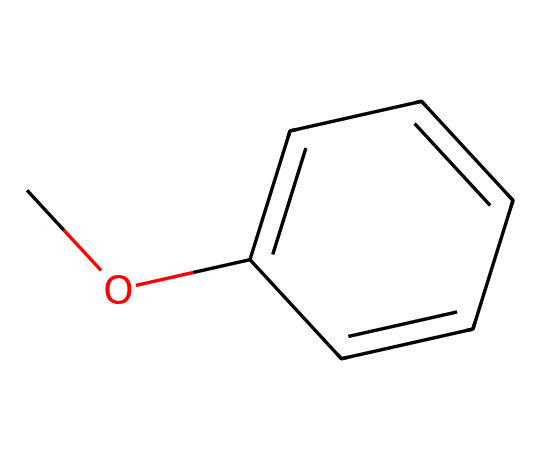What is the molecular formula of this compound? By analyzing the SMILES representation, we see that the compound consists of one carbon atom in the methoxy (-OCH3) group and six carbon atoms in the benzene ring, along with six hydrogen atoms from the benzene and three from the methoxy group. Thus, the total molecular formula is C8H10O.
Answer: C8H10O How many carbon atoms are in methoxybenzene? The SMILES representation indicates that there are a total of eight carbon atoms: one from the methoxy group and seven from the benzene structure.
Answer: eight What type of functional group does this compound contain? The presence of the -OCH3 group indicates that this compound has an ether functional group, specifically methoxy, bonded to a benzene ring.
Answer: ether What is the boiling point of methoxybenzene? The typical boiling point for methoxybenzene is around 169 degrees Celsius, which reflects its aromatic characteristics and the presence of the ether functional group.
Answer: 169 degrees Celsius Does methoxybenzene have a noticeable scent? Yes, methoxybenzene has a sweet, anise-like scent reminiscent of compounds found in O. Henry's works, which is characteristic of substances containing similar structures.
Answer: Yes How does methoxybenzene differ from benzene in terms of chemical properties? Methoxybenzene has an ether group that alters its reactivity and solubility compared to benzene, which is purely hydrocarbon and less polar.
Answer: Different reactivity 